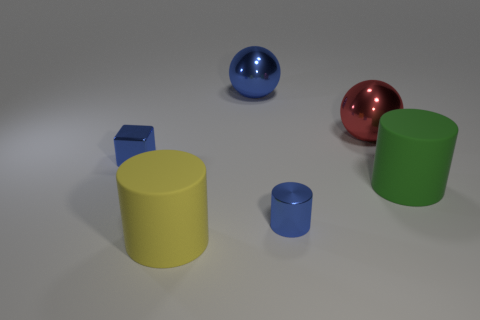What time of day does the lighting in this image suggest? The image appears to be artificially lit, given the uniformity and softness of the shadows, suggesting an indoor setting rather than a specific time of day. The source of the light seems diffused, without a direct or harsh intensity that one would associate with natural sunlight. 